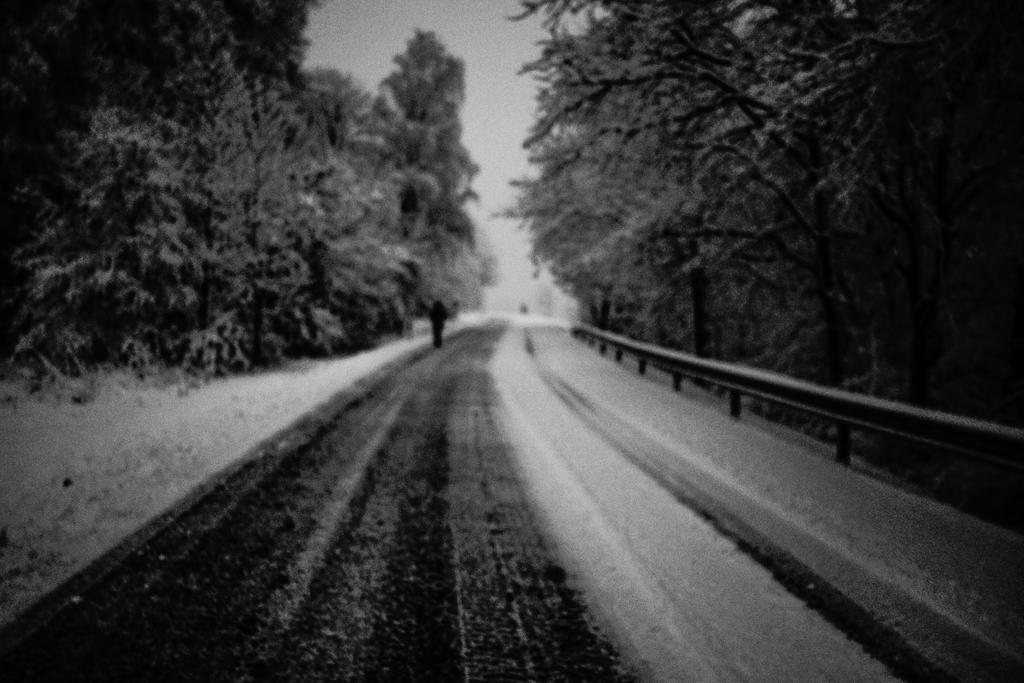Please provide a concise description of this image. On either side of the road we can see trees. A person on the road. 